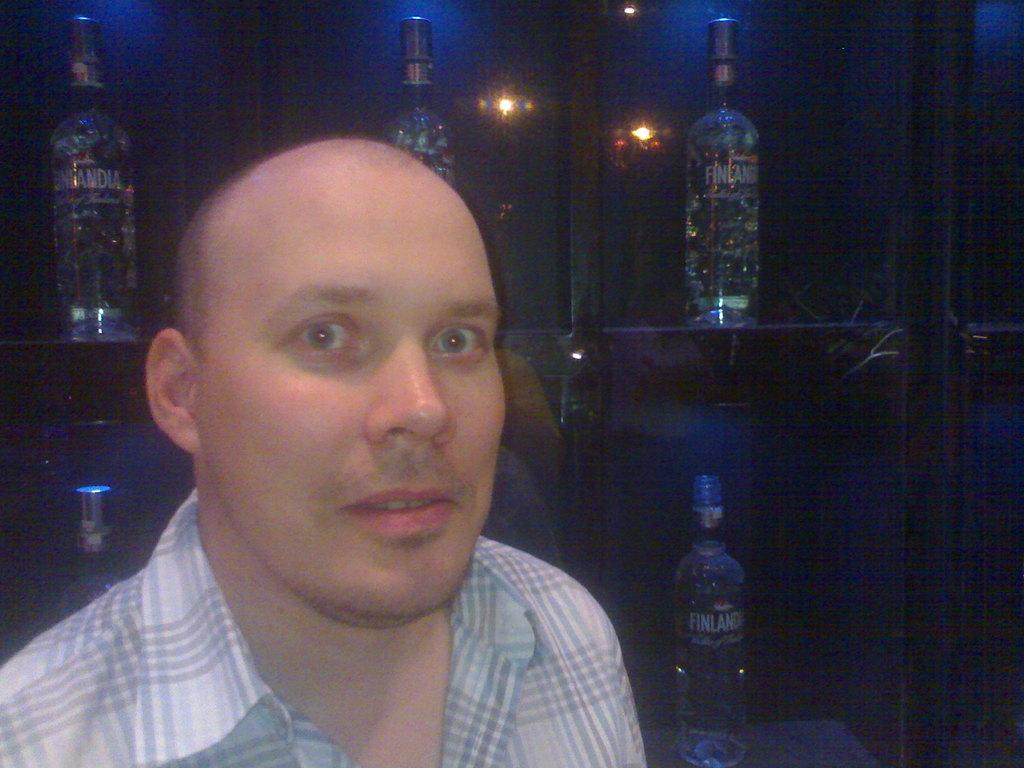Who is present in the image? There is a person in the image. What is the person doing in the image? The person is smiling. What is the person wearing in the image? The person is wearing a shirt. What can be seen in the background of the image? There is a big shelf in the background of the image. What is placed on the shelf? There are bottles placed on the shelf. What type of string is being used to tie the person's shoes in the image? There is no string visible in the image, nor is there any indication that the person's shoes are tied. 